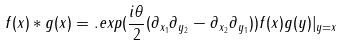<formula> <loc_0><loc_0><loc_500><loc_500>f ( x ) * g ( x ) = . e x p ( \frac { i \theta } { 2 } ( \partial _ { x _ { 1 } } \partial _ { y _ { 2 } } - \partial _ { x _ { 2 } } \partial _ { y _ { 1 } } ) ) f ( x ) g ( y ) | _ { y = x }</formula> 